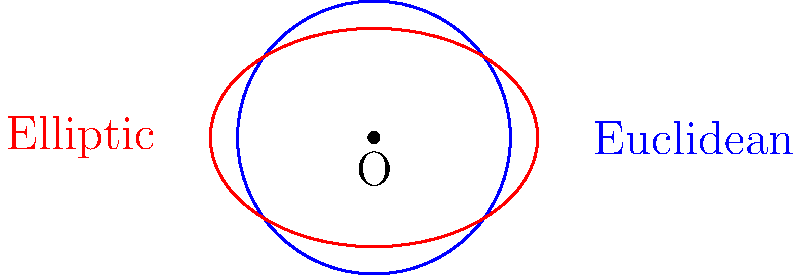In the context of corporate regulation and tax policy, consider how different geometric models might represent economic systems. The blue circle represents a Euclidean model, while the red ellipse represents an elliptic geometry model. How does the concept of "great circles" in elliptic geometry relate to the idea of wealth distribution in a progressive economic system? To answer this question, let's break down the concepts step-by-step:

1. In Euclidean geometry, circles are defined by points equidistant from a center. This can be seen as analogous to a "trickle-down" economic model, where wealth is assumed to spread evenly from a central point.

2. In elliptic geometry, all lines are "great circles," similar to lines of longitude on a globe. This concept can be related to a more progressive economic model:

   a) Great circles always return to their starting point, suggesting a more cyclical view of wealth distribution.
   
   b) The shortest path between two points in elliptic geometry is along a great circle, which could represent efficient wealth redistribution policies.

3. In elliptic geometry, parallel lines do not exist, and all lines eventually intersect. This can be interpreted as:

   a) All economic policies and actions are interconnected.
   
   b) There's no such thing as completely separate economic classes; all parts of the economy ultimately affect each other.

4. The "constant curvature" of elliptic geometry implies that economic policies should have consistent effects regardless of scale, supporting the idea of progressive taxation at all income levels.

5. Just as elliptic geometry challenges our intuitive understanding of space, progressive economic policies often challenge traditional economic assumptions.

In this context, "great circles" in elliptic geometry can be seen as representing comprehensive, far-reaching economic policies that affect all parts of the economy equally, much like how progressive taxation and corporate regulation aim to create a more equitable distribution of wealth.
Answer: Great circles represent comprehensive economic policies promoting equitable wealth distribution. 